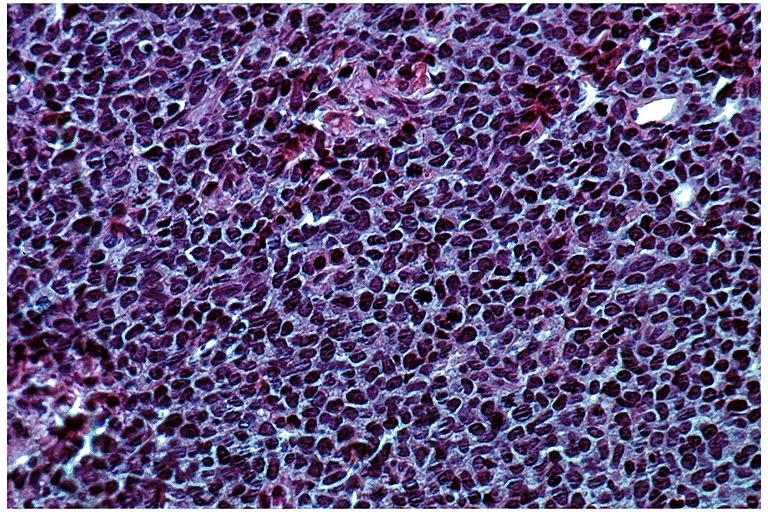where is this?
Answer the question using a single word or phrase. Oral 